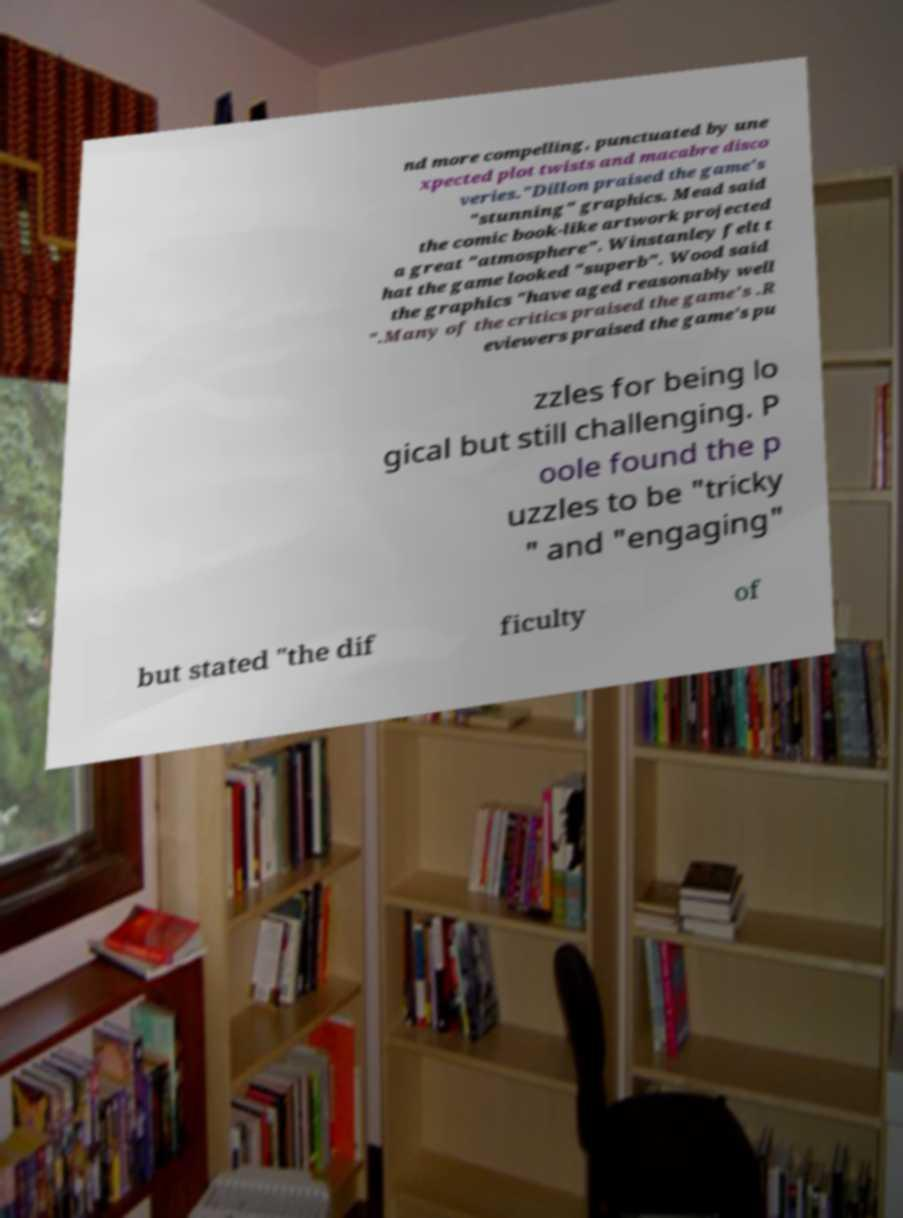Can you read and provide the text displayed in the image?This photo seems to have some interesting text. Can you extract and type it out for me? nd more compelling, punctuated by une xpected plot twists and macabre disco veries."Dillon praised the game's "stunning" graphics. Mead said the comic book-like artwork projected a great "atmosphere". Winstanley felt t hat the game looked "superb". Wood said the graphics "have aged reasonably well ".Many of the critics praised the game's .R eviewers praised the game's pu zzles for being lo gical but still challenging. P oole found the p uzzles to be "tricky " and "engaging" but stated "the dif ficulty of 